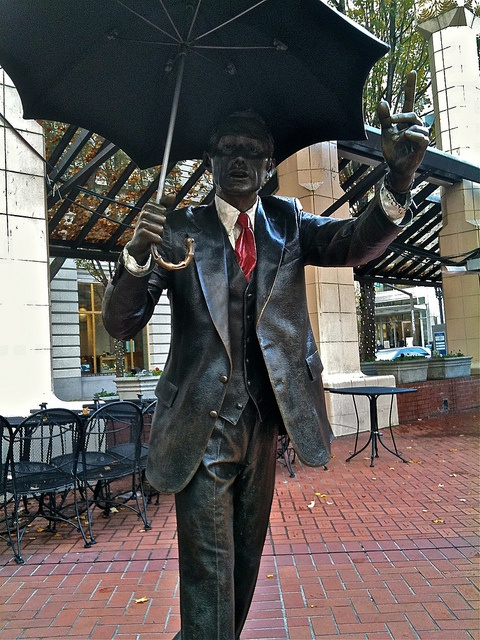Describe the objects in this image and their specific colors. I can see umbrella in purple, black, gray, and darkblue tones, chair in purple, black, gray, darkgray, and darkblue tones, chair in purple, black, gray, darkblue, and blue tones, dining table in purple, darkgray, black, and gray tones, and chair in purple, black, gray, and darkgray tones in this image. 